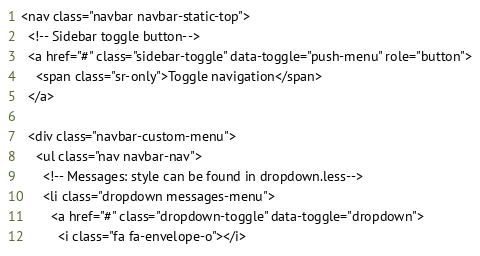Convert code to text. <code><loc_0><loc_0><loc_500><loc_500><_PHP_><nav class="navbar navbar-static-top">
  <!-- Sidebar toggle button-->
  <a href="#" class="sidebar-toggle" data-toggle="push-menu" role="button">
    <span class="sr-only">Toggle navigation</span>
  </a>

  <div class="navbar-custom-menu">
    <ul class="nav navbar-nav">
      <!-- Messages: style can be found in dropdown.less-->
      <li class="dropdown messages-menu">
        <a href="#" class="dropdown-toggle" data-toggle="dropdown">
          <i class="fa fa-envelope-o"></i></code> 